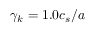<formula> <loc_0><loc_0><loc_500><loc_500>\gamma _ { k } = 1 . 0 c _ { s } / a</formula> 